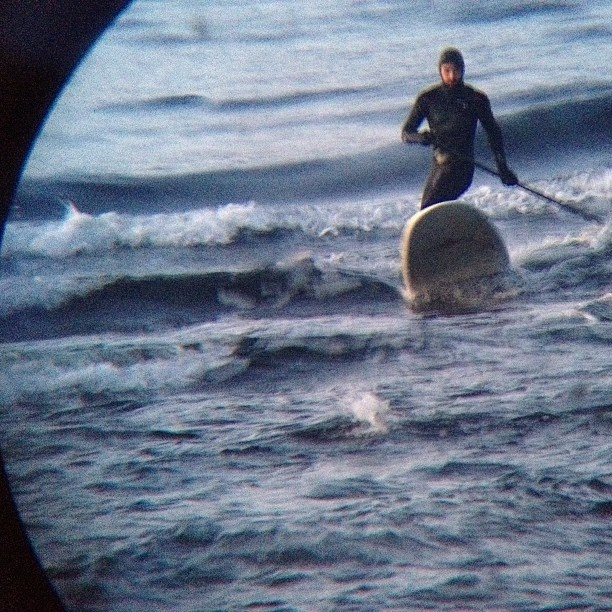Describe the objects in this image and their specific colors. I can see surfboard in black, gray, and darkgray tones and people in black, gray, navy, and darkgray tones in this image. 